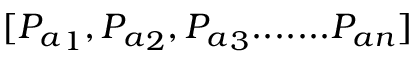<formula> <loc_0><loc_0><loc_500><loc_500>[ { P _ { a } } _ { 1 } , { P _ { a } } _ { 2 } , { P _ { a } } _ { 3 } \cdots \dots { P _ { a n } } ]</formula> 